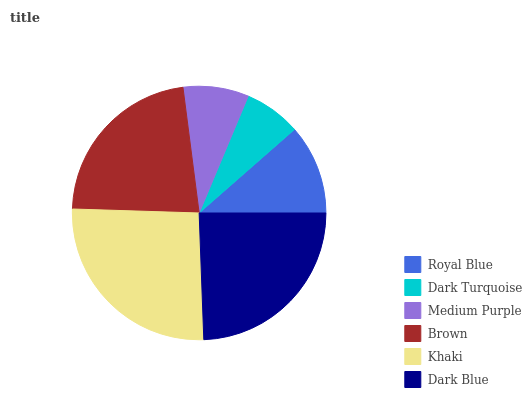Is Dark Turquoise the minimum?
Answer yes or no. Yes. Is Khaki the maximum?
Answer yes or no. Yes. Is Medium Purple the minimum?
Answer yes or no. No. Is Medium Purple the maximum?
Answer yes or no. No. Is Medium Purple greater than Dark Turquoise?
Answer yes or no. Yes. Is Dark Turquoise less than Medium Purple?
Answer yes or no. Yes. Is Dark Turquoise greater than Medium Purple?
Answer yes or no. No. Is Medium Purple less than Dark Turquoise?
Answer yes or no. No. Is Brown the high median?
Answer yes or no. Yes. Is Royal Blue the low median?
Answer yes or no. Yes. Is Khaki the high median?
Answer yes or no. No. Is Brown the low median?
Answer yes or no. No. 